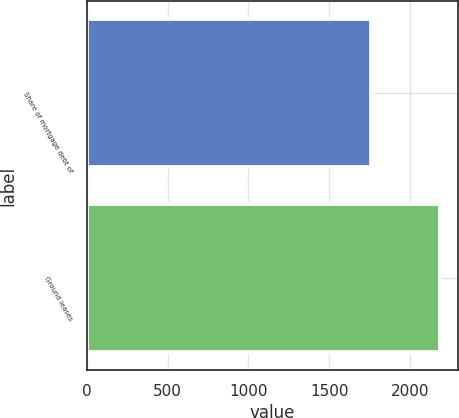Convert chart to OTSL. <chart><loc_0><loc_0><loc_500><loc_500><bar_chart><fcel>Share of mortgage debt of<fcel>Ground leases<nl><fcel>1757<fcel>2185<nl></chart> 